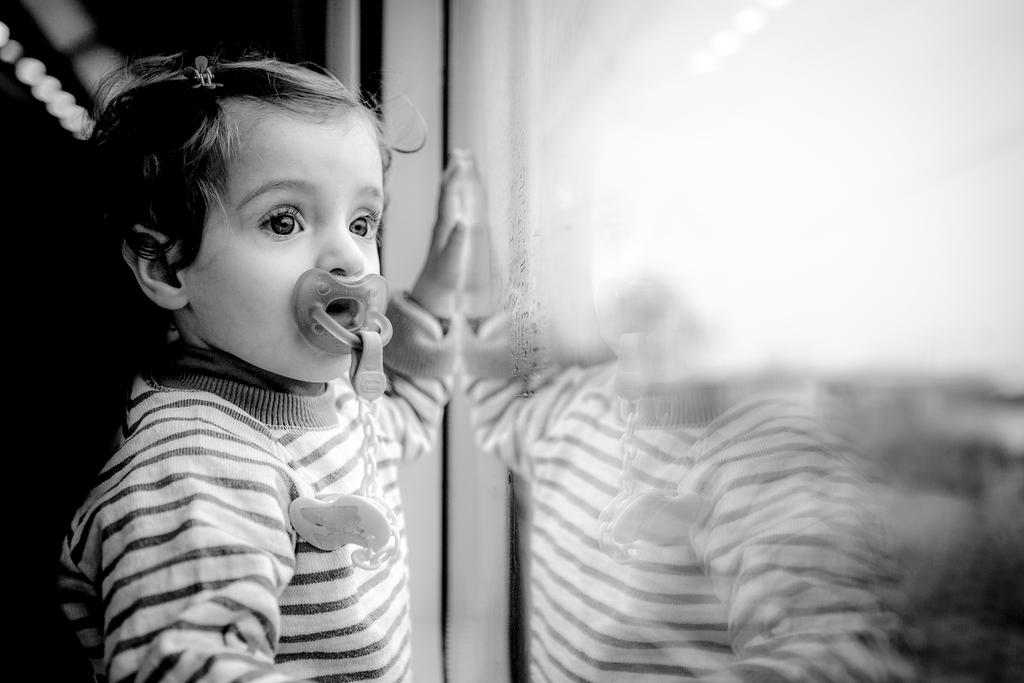What is the main subject of the image? The main subject of the image is a small kid. What is the kid doing in the image? The kid is standing in the image. What is the kid holding in their mouth? The kid is holding an object in their mouth. What type of insect can be seen building a nest in the image? There is no insect or nest present in the image; it features a small kid standing and holding an object in their mouth. 